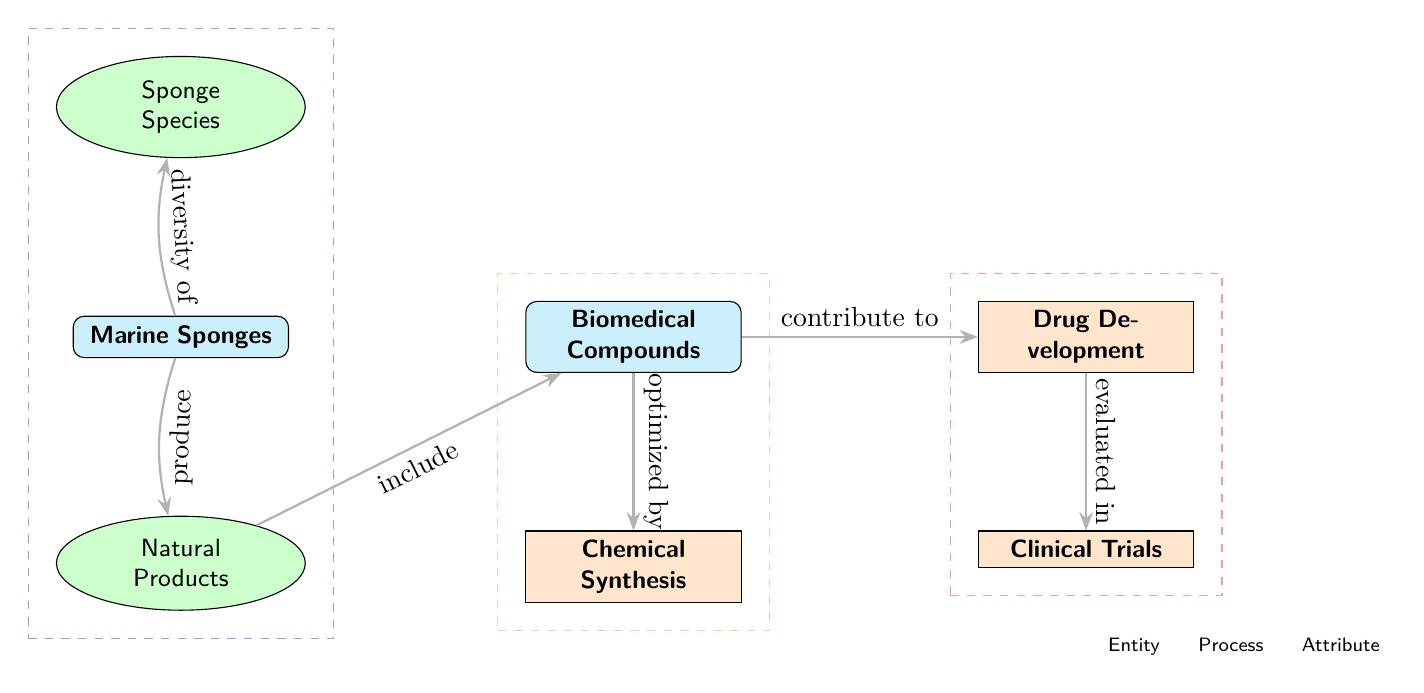What are the primary entities depicted in the diagram? The diagram shows two primary entities which are Marine Sponges and Biomedical Compounds. The entities are represented in the diagram by rectangles filled with cyan.
Answer: Marine Sponges, Biomedical Compounds What process is linked to drug development in the diagram? The diagram shows that Drug Development is connected to Clinical Trials, indicating that the development process undergoes evaluation in clinical trials.
Answer: Clinical Trials How many attributes are associated with Marine Sponges in the diagram? There are two attributes linked to Marine Sponges: Sponge Species (above) and Natural Products (below).
Answer: 2 What relationship describes the production of compounds from sponges? The diagram identifies the relationship where Marine Sponges "produce" Natural Products, which in turn "include" Biomedical Compounds.
Answer: produce Which process follows the optimization of compounds? After the compounds are optimized by Chemical Synthesis, they contribute to Drug Development. This means that the next logical step is Drug Development.
Answer: Drug Development How do Biomedical Compounds get synthesized according to the diagram? The diagram indicates that Biomedical Compounds are "optimized by" a process called Chemical Synthesis, indicating an important step in their production.
Answer: Chemical Synthesis What overall category does the diagram depict about the relationship between sponges and drug discovery? The overarching theme represented in the diagram is the role that Marine Sponges play in the discovery and development of Biomedical Compounds aimed at drug development.
Answer: Role of Marine Sponges What type of relationship exists between the Natural Products and Biomedical Compounds in the diagram? Natural Products are stated in the diagram to "include" Biomedical Compounds, signifying a foundational or supportive connection between these two entities.
Answer: include 